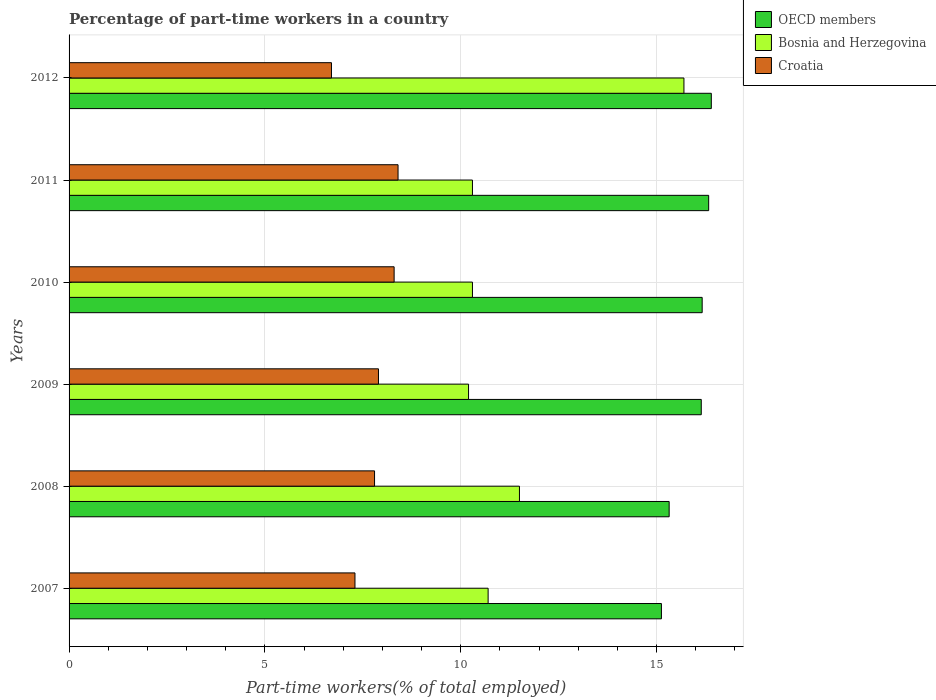How many groups of bars are there?
Your response must be concise. 6. Are the number of bars per tick equal to the number of legend labels?
Your answer should be compact. Yes. Are the number of bars on each tick of the Y-axis equal?
Your response must be concise. Yes. How many bars are there on the 2nd tick from the top?
Your answer should be very brief. 3. What is the label of the 3rd group of bars from the top?
Make the answer very short. 2010. In how many cases, is the number of bars for a given year not equal to the number of legend labels?
Ensure brevity in your answer.  0. What is the percentage of part-time workers in Croatia in 2011?
Keep it short and to the point. 8.4. Across all years, what is the maximum percentage of part-time workers in Bosnia and Herzegovina?
Your answer should be very brief. 15.7. Across all years, what is the minimum percentage of part-time workers in Bosnia and Herzegovina?
Give a very brief answer. 10.2. What is the total percentage of part-time workers in Bosnia and Herzegovina in the graph?
Provide a short and direct response. 68.7. What is the difference between the percentage of part-time workers in Bosnia and Herzegovina in 2010 and that in 2012?
Provide a succinct answer. -5.4. What is the difference between the percentage of part-time workers in Bosnia and Herzegovina in 2007 and the percentage of part-time workers in OECD members in 2012?
Provide a short and direct response. -5.7. What is the average percentage of part-time workers in OECD members per year?
Your answer should be very brief. 15.91. In the year 2008, what is the difference between the percentage of part-time workers in Bosnia and Herzegovina and percentage of part-time workers in Croatia?
Give a very brief answer. 3.7. What is the ratio of the percentage of part-time workers in OECD members in 2007 to that in 2009?
Your answer should be very brief. 0.94. Is the difference between the percentage of part-time workers in Bosnia and Herzegovina in 2010 and 2011 greater than the difference between the percentage of part-time workers in Croatia in 2010 and 2011?
Keep it short and to the point. Yes. What is the difference between the highest and the second highest percentage of part-time workers in Croatia?
Make the answer very short. 0.1. What is the difference between the highest and the lowest percentage of part-time workers in OECD members?
Give a very brief answer. 1.27. Is the sum of the percentage of part-time workers in Bosnia and Herzegovina in 2010 and 2012 greater than the maximum percentage of part-time workers in OECD members across all years?
Make the answer very short. Yes. What does the 1st bar from the top in 2011 represents?
Offer a terse response. Croatia. What does the 1st bar from the bottom in 2010 represents?
Provide a short and direct response. OECD members. Are all the bars in the graph horizontal?
Your answer should be compact. Yes. What is the difference between two consecutive major ticks on the X-axis?
Your answer should be compact. 5. Are the values on the major ticks of X-axis written in scientific E-notation?
Provide a succinct answer. No. Does the graph contain any zero values?
Keep it short and to the point. No. Where does the legend appear in the graph?
Your response must be concise. Top right. How many legend labels are there?
Your answer should be very brief. 3. How are the legend labels stacked?
Provide a short and direct response. Vertical. What is the title of the graph?
Provide a short and direct response. Percentage of part-time workers in a country. Does "Arab World" appear as one of the legend labels in the graph?
Give a very brief answer. No. What is the label or title of the X-axis?
Your answer should be compact. Part-time workers(% of total employed). What is the Part-time workers(% of total employed) of OECD members in 2007?
Ensure brevity in your answer.  15.12. What is the Part-time workers(% of total employed) of Bosnia and Herzegovina in 2007?
Ensure brevity in your answer.  10.7. What is the Part-time workers(% of total employed) in Croatia in 2007?
Provide a succinct answer. 7.3. What is the Part-time workers(% of total employed) of OECD members in 2008?
Your answer should be compact. 15.32. What is the Part-time workers(% of total employed) in Bosnia and Herzegovina in 2008?
Offer a very short reply. 11.5. What is the Part-time workers(% of total employed) in Croatia in 2008?
Your answer should be compact. 7.8. What is the Part-time workers(% of total employed) in OECD members in 2009?
Offer a terse response. 16.14. What is the Part-time workers(% of total employed) of Bosnia and Herzegovina in 2009?
Keep it short and to the point. 10.2. What is the Part-time workers(% of total employed) of Croatia in 2009?
Offer a very short reply. 7.9. What is the Part-time workers(% of total employed) in OECD members in 2010?
Ensure brevity in your answer.  16.17. What is the Part-time workers(% of total employed) in Bosnia and Herzegovina in 2010?
Offer a terse response. 10.3. What is the Part-time workers(% of total employed) of Croatia in 2010?
Your answer should be very brief. 8.3. What is the Part-time workers(% of total employed) in OECD members in 2011?
Give a very brief answer. 16.33. What is the Part-time workers(% of total employed) of Bosnia and Herzegovina in 2011?
Provide a short and direct response. 10.3. What is the Part-time workers(% of total employed) in Croatia in 2011?
Provide a short and direct response. 8.4. What is the Part-time workers(% of total employed) in OECD members in 2012?
Give a very brief answer. 16.4. What is the Part-time workers(% of total employed) of Bosnia and Herzegovina in 2012?
Your answer should be compact. 15.7. What is the Part-time workers(% of total employed) of Croatia in 2012?
Provide a succinct answer. 6.7. Across all years, what is the maximum Part-time workers(% of total employed) of OECD members?
Your answer should be compact. 16.4. Across all years, what is the maximum Part-time workers(% of total employed) in Bosnia and Herzegovina?
Make the answer very short. 15.7. Across all years, what is the maximum Part-time workers(% of total employed) of Croatia?
Ensure brevity in your answer.  8.4. Across all years, what is the minimum Part-time workers(% of total employed) in OECD members?
Keep it short and to the point. 15.12. Across all years, what is the minimum Part-time workers(% of total employed) in Bosnia and Herzegovina?
Your response must be concise. 10.2. Across all years, what is the minimum Part-time workers(% of total employed) in Croatia?
Make the answer very short. 6.7. What is the total Part-time workers(% of total employed) in OECD members in the graph?
Provide a short and direct response. 95.49. What is the total Part-time workers(% of total employed) in Bosnia and Herzegovina in the graph?
Offer a very short reply. 68.7. What is the total Part-time workers(% of total employed) of Croatia in the graph?
Provide a short and direct response. 46.4. What is the difference between the Part-time workers(% of total employed) in OECD members in 2007 and that in 2008?
Give a very brief answer. -0.2. What is the difference between the Part-time workers(% of total employed) in Bosnia and Herzegovina in 2007 and that in 2008?
Offer a terse response. -0.8. What is the difference between the Part-time workers(% of total employed) of OECD members in 2007 and that in 2009?
Your answer should be compact. -1.02. What is the difference between the Part-time workers(% of total employed) of OECD members in 2007 and that in 2010?
Offer a terse response. -1.04. What is the difference between the Part-time workers(% of total employed) in Bosnia and Herzegovina in 2007 and that in 2010?
Give a very brief answer. 0.4. What is the difference between the Part-time workers(% of total employed) of OECD members in 2007 and that in 2011?
Offer a very short reply. -1.21. What is the difference between the Part-time workers(% of total employed) in Bosnia and Herzegovina in 2007 and that in 2011?
Your answer should be compact. 0.4. What is the difference between the Part-time workers(% of total employed) in Croatia in 2007 and that in 2011?
Your answer should be very brief. -1.1. What is the difference between the Part-time workers(% of total employed) of OECD members in 2007 and that in 2012?
Provide a short and direct response. -1.27. What is the difference between the Part-time workers(% of total employed) of OECD members in 2008 and that in 2009?
Provide a short and direct response. -0.82. What is the difference between the Part-time workers(% of total employed) in Bosnia and Herzegovina in 2008 and that in 2009?
Give a very brief answer. 1.3. What is the difference between the Part-time workers(% of total employed) in OECD members in 2008 and that in 2010?
Offer a terse response. -0.84. What is the difference between the Part-time workers(% of total employed) of Bosnia and Herzegovina in 2008 and that in 2010?
Offer a very short reply. 1.2. What is the difference between the Part-time workers(% of total employed) of Croatia in 2008 and that in 2010?
Provide a succinct answer. -0.5. What is the difference between the Part-time workers(% of total employed) in OECD members in 2008 and that in 2011?
Keep it short and to the point. -1.01. What is the difference between the Part-time workers(% of total employed) of OECD members in 2008 and that in 2012?
Provide a succinct answer. -1.08. What is the difference between the Part-time workers(% of total employed) in Bosnia and Herzegovina in 2008 and that in 2012?
Ensure brevity in your answer.  -4.2. What is the difference between the Part-time workers(% of total employed) of OECD members in 2009 and that in 2010?
Give a very brief answer. -0.02. What is the difference between the Part-time workers(% of total employed) of Bosnia and Herzegovina in 2009 and that in 2010?
Keep it short and to the point. -0.1. What is the difference between the Part-time workers(% of total employed) in Croatia in 2009 and that in 2010?
Provide a succinct answer. -0.4. What is the difference between the Part-time workers(% of total employed) in OECD members in 2009 and that in 2011?
Give a very brief answer. -0.19. What is the difference between the Part-time workers(% of total employed) of Bosnia and Herzegovina in 2009 and that in 2011?
Provide a short and direct response. -0.1. What is the difference between the Part-time workers(% of total employed) in OECD members in 2009 and that in 2012?
Offer a terse response. -0.26. What is the difference between the Part-time workers(% of total employed) of Croatia in 2009 and that in 2012?
Offer a terse response. 1.2. What is the difference between the Part-time workers(% of total employed) in OECD members in 2010 and that in 2011?
Offer a very short reply. -0.17. What is the difference between the Part-time workers(% of total employed) of Croatia in 2010 and that in 2011?
Ensure brevity in your answer.  -0.1. What is the difference between the Part-time workers(% of total employed) of OECD members in 2010 and that in 2012?
Ensure brevity in your answer.  -0.23. What is the difference between the Part-time workers(% of total employed) of Bosnia and Herzegovina in 2010 and that in 2012?
Your answer should be compact. -5.4. What is the difference between the Part-time workers(% of total employed) of OECD members in 2011 and that in 2012?
Ensure brevity in your answer.  -0.07. What is the difference between the Part-time workers(% of total employed) of Bosnia and Herzegovina in 2011 and that in 2012?
Your answer should be compact. -5.4. What is the difference between the Part-time workers(% of total employed) in Croatia in 2011 and that in 2012?
Offer a terse response. 1.7. What is the difference between the Part-time workers(% of total employed) in OECD members in 2007 and the Part-time workers(% of total employed) in Bosnia and Herzegovina in 2008?
Ensure brevity in your answer.  3.62. What is the difference between the Part-time workers(% of total employed) in OECD members in 2007 and the Part-time workers(% of total employed) in Croatia in 2008?
Make the answer very short. 7.32. What is the difference between the Part-time workers(% of total employed) in OECD members in 2007 and the Part-time workers(% of total employed) in Bosnia and Herzegovina in 2009?
Provide a succinct answer. 4.92. What is the difference between the Part-time workers(% of total employed) of OECD members in 2007 and the Part-time workers(% of total employed) of Croatia in 2009?
Your answer should be very brief. 7.22. What is the difference between the Part-time workers(% of total employed) in OECD members in 2007 and the Part-time workers(% of total employed) in Bosnia and Herzegovina in 2010?
Provide a short and direct response. 4.82. What is the difference between the Part-time workers(% of total employed) in OECD members in 2007 and the Part-time workers(% of total employed) in Croatia in 2010?
Your answer should be very brief. 6.82. What is the difference between the Part-time workers(% of total employed) of OECD members in 2007 and the Part-time workers(% of total employed) of Bosnia and Herzegovina in 2011?
Offer a terse response. 4.82. What is the difference between the Part-time workers(% of total employed) in OECD members in 2007 and the Part-time workers(% of total employed) in Croatia in 2011?
Ensure brevity in your answer.  6.72. What is the difference between the Part-time workers(% of total employed) in OECD members in 2007 and the Part-time workers(% of total employed) in Bosnia and Herzegovina in 2012?
Ensure brevity in your answer.  -0.58. What is the difference between the Part-time workers(% of total employed) in OECD members in 2007 and the Part-time workers(% of total employed) in Croatia in 2012?
Ensure brevity in your answer.  8.42. What is the difference between the Part-time workers(% of total employed) of OECD members in 2008 and the Part-time workers(% of total employed) of Bosnia and Herzegovina in 2009?
Your answer should be very brief. 5.12. What is the difference between the Part-time workers(% of total employed) of OECD members in 2008 and the Part-time workers(% of total employed) of Croatia in 2009?
Your response must be concise. 7.42. What is the difference between the Part-time workers(% of total employed) in Bosnia and Herzegovina in 2008 and the Part-time workers(% of total employed) in Croatia in 2009?
Keep it short and to the point. 3.6. What is the difference between the Part-time workers(% of total employed) in OECD members in 2008 and the Part-time workers(% of total employed) in Bosnia and Herzegovina in 2010?
Give a very brief answer. 5.02. What is the difference between the Part-time workers(% of total employed) in OECD members in 2008 and the Part-time workers(% of total employed) in Croatia in 2010?
Provide a short and direct response. 7.02. What is the difference between the Part-time workers(% of total employed) of OECD members in 2008 and the Part-time workers(% of total employed) of Bosnia and Herzegovina in 2011?
Make the answer very short. 5.02. What is the difference between the Part-time workers(% of total employed) in OECD members in 2008 and the Part-time workers(% of total employed) in Croatia in 2011?
Provide a succinct answer. 6.92. What is the difference between the Part-time workers(% of total employed) in Bosnia and Herzegovina in 2008 and the Part-time workers(% of total employed) in Croatia in 2011?
Give a very brief answer. 3.1. What is the difference between the Part-time workers(% of total employed) of OECD members in 2008 and the Part-time workers(% of total employed) of Bosnia and Herzegovina in 2012?
Your answer should be compact. -0.38. What is the difference between the Part-time workers(% of total employed) in OECD members in 2008 and the Part-time workers(% of total employed) in Croatia in 2012?
Ensure brevity in your answer.  8.62. What is the difference between the Part-time workers(% of total employed) of OECD members in 2009 and the Part-time workers(% of total employed) of Bosnia and Herzegovina in 2010?
Offer a terse response. 5.84. What is the difference between the Part-time workers(% of total employed) of OECD members in 2009 and the Part-time workers(% of total employed) of Croatia in 2010?
Keep it short and to the point. 7.84. What is the difference between the Part-time workers(% of total employed) in OECD members in 2009 and the Part-time workers(% of total employed) in Bosnia and Herzegovina in 2011?
Your response must be concise. 5.84. What is the difference between the Part-time workers(% of total employed) of OECD members in 2009 and the Part-time workers(% of total employed) of Croatia in 2011?
Offer a terse response. 7.74. What is the difference between the Part-time workers(% of total employed) in Bosnia and Herzegovina in 2009 and the Part-time workers(% of total employed) in Croatia in 2011?
Your answer should be compact. 1.8. What is the difference between the Part-time workers(% of total employed) in OECD members in 2009 and the Part-time workers(% of total employed) in Bosnia and Herzegovina in 2012?
Provide a succinct answer. 0.44. What is the difference between the Part-time workers(% of total employed) of OECD members in 2009 and the Part-time workers(% of total employed) of Croatia in 2012?
Give a very brief answer. 9.44. What is the difference between the Part-time workers(% of total employed) of OECD members in 2010 and the Part-time workers(% of total employed) of Bosnia and Herzegovina in 2011?
Ensure brevity in your answer.  5.87. What is the difference between the Part-time workers(% of total employed) of OECD members in 2010 and the Part-time workers(% of total employed) of Croatia in 2011?
Offer a very short reply. 7.77. What is the difference between the Part-time workers(% of total employed) of OECD members in 2010 and the Part-time workers(% of total employed) of Bosnia and Herzegovina in 2012?
Give a very brief answer. 0.47. What is the difference between the Part-time workers(% of total employed) in OECD members in 2010 and the Part-time workers(% of total employed) in Croatia in 2012?
Keep it short and to the point. 9.47. What is the difference between the Part-time workers(% of total employed) in Bosnia and Herzegovina in 2010 and the Part-time workers(% of total employed) in Croatia in 2012?
Make the answer very short. 3.6. What is the difference between the Part-time workers(% of total employed) of OECD members in 2011 and the Part-time workers(% of total employed) of Bosnia and Herzegovina in 2012?
Offer a terse response. 0.63. What is the difference between the Part-time workers(% of total employed) in OECD members in 2011 and the Part-time workers(% of total employed) in Croatia in 2012?
Ensure brevity in your answer.  9.63. What is the average Part-time workers(% of total employed) in OECD members per year?
Ensure brevity in your answer.  15.91. What is the average Part-time workers(% of total employed) in Bosnia and Herzegovina per year?
Your answer should be very brief. 11.45. What is the average Part-time workers(% of total employed) of Croatia per year?
Your answer should be compact. 7.73. In the year 2007, what is the difference between the Part-time workers(% of total employed) in OECD members and Part-time workers(% of total employed) in Bosnia and Herzegovina?
Your response must be concise. 4.42. In the year 2007, what is the difference between the Part-time workers(% of total employed) in OECD members and Part-time workers(% of total employed) in Croatia?
Offer a very short reply. 7.82. In the year 2008, what is the difference between the Part-time workers(% of total employed) in OECD members and Part-time workers(% of total employed) in Bosnia and Herzegovina?
Offer a terse response. 3.82. In the year 2008, what is the difference between the Part-time workers(% of total employed) in OECD members and Part-time workers(% of total employed) in Croatia?
Your response must be concise. 7.52. In the year 2009, what is the difference between the Part-time workers(% of total employed) in OECD members and Part-time workers(% of total employed) in Bosnia and Herzegovina?
Keep it short and to the point. 5.94. In the year 2009, what is the difference between the Part-time workers(% of total employed) of OECD members and Part-time workers(% of total employed) of Croatia?
Your answer should be compact. 8.24. In the year 2009, what is the difference between the Part-time workers(% of total employed) in Bosnia and Herzegovina and Part-time workers(% of total employed) in Croatia?
Offer a terse response. 2.3. In the year 2010, what is the difference between the Part-time workers(% of total employed) of OECD members and Part-time workers(% of total employed) of Bosnia and Herzegovina?
Your answer should be compact. 5.87. In the year 2010, what is the difference between the Part-time workers(% of total employed) of OECD members and Part-time workers(% of total employed) of Croatia?
Ensure brevity in your answer.  7.87. In the year 2010, what is the difference between the Part-time workers(% of total employed) in Bosnia and Herzegovina and Part-time workers(% of total employed) in Croatia?
Make the answer very short. 2. In the year 2011, what is the difference between the Part-time workers(% of total employed) of OECD members and Part-time workers(% of total employed) of Bosnia and Herzegovina?
Provide a short and direct response. 6.03. In the year 2011, what is the difference between the Part-time workers(% of total employed) of OECD members and Part-time workers(% of total employed) of Croatia?
Provide a succinct answer. 7.93. In the year 2011, what is the difference between the Part-time workers(% of total employed) in Bosnia and Herzegovina and Part-time workers(% of total employed) in Croatia?
Keep it short and to the point. 1.9. In the year 2012, what is the difference between the Part-time workers(% of total employed) in OECD members and Part-time workers(% of total employed) in Bosnia and Herzegovina?
Keep it short and to the point. 0.7. In the year 2012, what is the difference between the Part-time workers(% of total employed) of OECD members and Part-time workers(% of total employed) of Croatia?
Keep it short and to the point. 9.7. In the year 2012, what is the difference between the Part-time workers(% of total employed) in Bosnia and Herzegovina and Part-time workers(% of total employed) in Croatia?
Your response must be concise. 9. What is the ratio of the Part-time workers(% of total employed) in OECD members in 2007 to that in 2008?
Offer a terse response. 0.99. What is the ratio of the Part-time workers(% of total employed) of Bosnia and Herzegovina in 2007 to that in 2008?
Provide a short and direct response. 0.93. What is the ratio of the Part-time workers(% of total employed) of Croatia in 2007 to that in 2008?
Ensure brevity in your answer.  0.94. What is the ratio of the Part-time workers(% of total employed) of OECD members in 2007 to that in 2009?
Give a very brief answer. 0.94. What is the ratio of the Part-time workers(% of total employed) in Bosnia and Herzegovina in 2007 to that in 2009?
Your answer should be compact. 1.05. What is the ratio of the Part-time workers(% of total employed) of Croatia in 2007 to that in 2009?
Offer a very short reply. 0.92. What is the ratio of the Part-time workers(% of total employed) in OECD members in 2007 to that in 2010?
Offer a terse response. 0.94. What is the ratio of the Part-time workers(% of total employed) of Bosnia and Herzegovina in 2007 to that in 2010?
Make the answer very short. 1.04. What is the ratio of the Part-time workers(% of total employed) in Croatia in 2007 to that in 2010?
Offer a very short reply. 0.88. What is the ratio of the Part-time workers(% of total employed) in OECD members in 2007 to that in 2011?
Your response must be concise. 0.93. What is the ratio of the Part-time workers(% of total employed) in Bosnia and Herzegovina in 2007 to that in 2011?
Provide a short and direct response. 1.04. What is the ratio of the Part-time workers(% of total employed) of Croatia in 2007 to that in 2011?
Your answer should be compact. 0.87. What is the ratio of the Part-time workers(% of total employed) of OECD members in 2007 to that in 2012?
Keep it short and to the point. 0.92. What is the ratio of the Part-time workers(% of total employed) of Bosnia and Herzegovina in 2007 to that in 2012?
Your answer should be very brief. 0.68. What is the ratio of the Part-time workers(% of total employed) of Croatia in 2007 to that in 2012?
Provide a succinct answer. 1.09. What is the ratio of the Part-time workers(% of total employed) of OECD members in 2008 to that in 2009?
Offer a very short reply. 0.95. What is the ratio of the Part-time workers(% of total employed) in Bosnia and Herzegovina in 2008 to that in 2009?
Provide a succinct answer. 1.13. What is the ratio of the Part-time workers(% of total employed) in Croatia in 2008 to that in 2009?
Ensure brevity in your answer.  0.99. What is the ratio of the Part-time workers(% of total employed) in OECD members in 2008 to that in 2010?
Offer a terse response. 0.95. What is the ratio of the Part-time workers(% of total employed) in Bosnia and Herzegovina in 2008 to that in 2010?
Your answer should be very brief. 1.12. What is the ratio of the Part-time workers(% of total employed) in Croatia in 2008 to that in 2010?
Offer a very short reply. 0.94. What is the ratio of the Part-time workers(% of total employed) of OECD members in 2008 to that in 2011?
Ensure brevity in your answer.  0.94. What is the ratio of the Part-time workers(% of total employed) in Bosnia and Herzegovina in 2008 to that in 2011?
Your answer should be very brief. 1.12. What is the ratio of the Part-time workers(% of total employed) of Croatia in 2008 to that in 2011?
Your response must be concise. 0.93. What is the ratio of the Part-time workers(% of total employed) in OECD members in 2008 to that in 2012?
Give a very brief answer. 0.93. What is the ratio of the Part-time workers(% of total employed) in Bosnia and Herzegovina in 2008 to that in 2012?
Your answer should be compact. 0.73. What is the ratio of the Part-time workers(% of total employed) of Croatia in 2008 to that in 2012?
Provide a short and direct response. 1.16. What is the ratio of the Part-time workers(% of total employed) in OECD members in 2009 to that in 2010?
Provide a succinct answer. 1. What is the ratio of the Part-time workers(% of total employed) of Bosnia and Herzegovina in 2009 to that in 2010?
Keep it short and to the point. 0.99. What is the ratio of the Part-time workers(% of total employed) in Croatia in 2009 to that in 2010?
Provide a short and direct response. 0.95. What is the ratio of the Part-time workers(% of total employed) of OECD members in 2009 to that in 2011?
Your answer should be very brief. 0.99. What is the ratio of the Part-time workers(% of total employed) of Bosnia and Herzegovina in 2009 to that in 2011?
Your response must be concise. 0.99. What is the ratio of the Part-time workers(% of total employed) in Croatia in 2009 to that in 2011?
Your answer should be compact. 0.94. What is the ratio of the Part-time workers(% of total employed) in OECD members in 2009 to that in 2012?
Your response must be concise. 0.98. What is the ratio of the Part-time workers(% of total employed) in Bosnia and Herzegovina in 2009 to that in 2012?
Offer a very short reply. 0.65. What is the ratio of the Part-time workers(% of total employed) in Croatia in 2009 to that in 2012?
Give a very brief answer. 1.18. What is the ratio of the Part-time workers(% of total employed) of Bosnia and Herzegovina in 2010 to that in 2011?
Ensure brevity in your answer.  1. What is the ratio of the Part-time workers(% of total employed) of OECD members in 2010 to that in 2012?
Ensure brevity in your answer.  0.99. What is the ratio of the Part-time workers(% of total employed) in Bosnia and Herzegovina in 2010 to that in 2012?
Give a very brief answer. 0.66. What is the ratio of the Part-time workers(% of total employed) in Croatia in 2010 to that in 2012?
Offer a very short reply. 1.24. What is the ratio of the Part-time workers(% of total employed) of OECD members in 2011 to that in 2012?
Your response must be concise. 1. What is the ratio of the Part-time workers(% of total employed) of Bosnia and Herzegovina in 2011 to that in 2012?
Your answer should be compact. 0.66. What is the ratio of the Part-time workers(% of total employed) in Croatia in 2011 to that in 2012?
Provide a short and direct response. 1.25. What is the difference between the highest and the second highest Part-time workers(% of total employed) of OECD members?
Provide a succinct answer. 0.07. What is the difference between the highest and the second highest Part-time workers(% of total employed) in Croatia?
Your response must be concise. 0.1. What is the difference between the highest and the lowest Part-time workers(% of total employed) of OECD members?
Your answer should be compact. 1.27. What is the difference between the highest and the lowest Part-time workers(% of total employed) in Bosnia and Herzegovina?
Your answer should be compact. 5.5. 